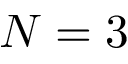Convert formula to latex. <formula><loc_0><loc_0><loc_500><loc_500>N = 3</formula> 